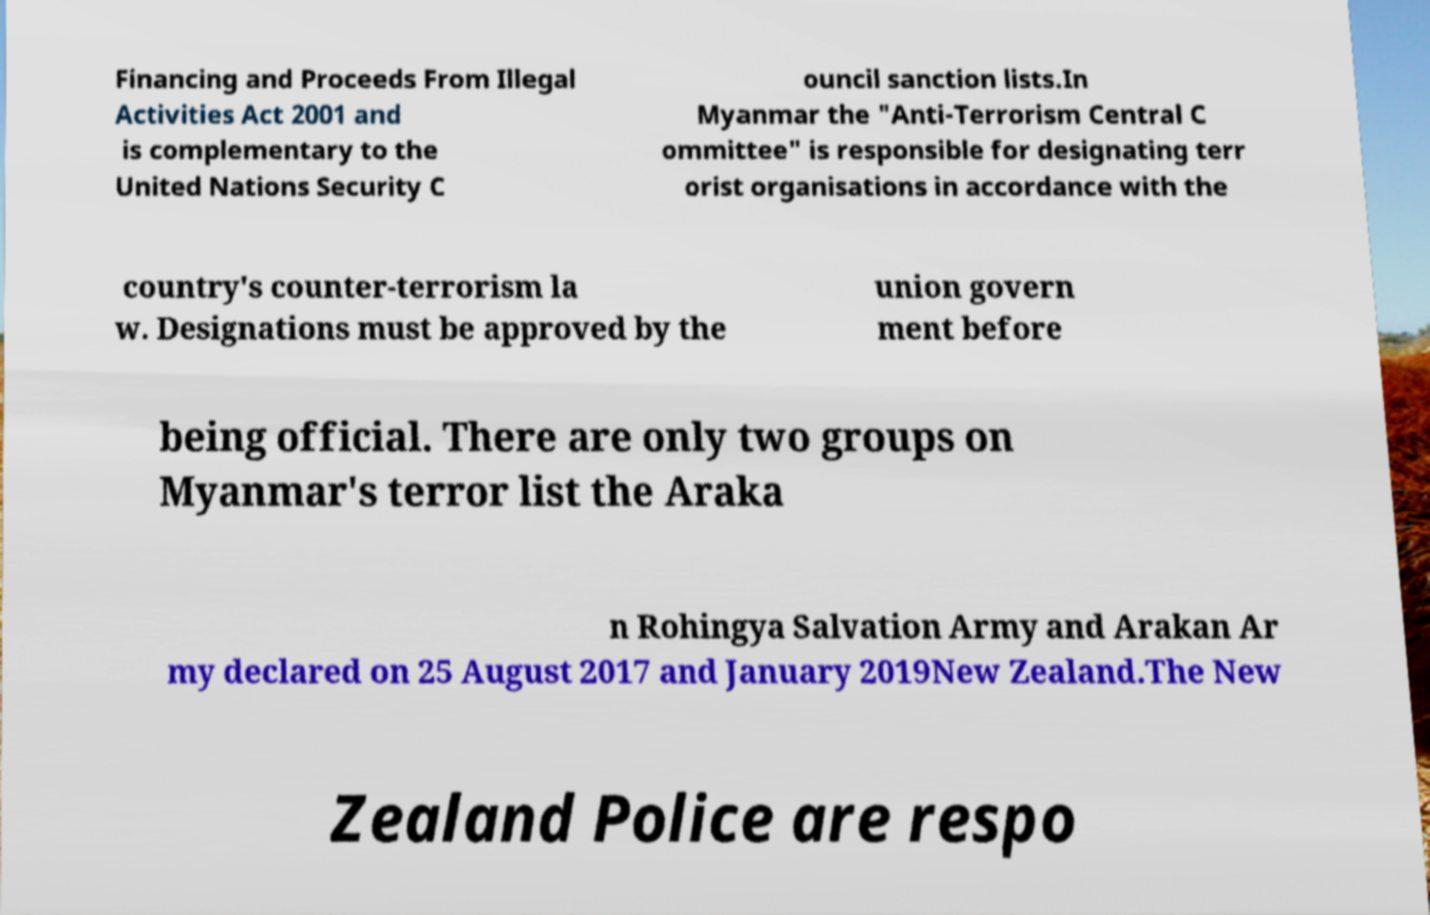Could you assist in decoding the text presented in this image and type it out clearly? Financing and Proceeds From Illegal Activities Act 2001 and is complementary to the United Nations Security C ouncil sanction lists.In Myanmar the "Anti-Terrorism Central C ommittee" is responsible for designating terr orist organisations in accordance with the country's counter-terrorism la w. Designations must be approved by the union govern ment before being official. There are only two groups on Myanmar's terror list the Araka n Rohingya Salvation Army and Arakan Ar my declared on 25 August 2017 and January 2019New Zealand.The New Zealand Police are respo 